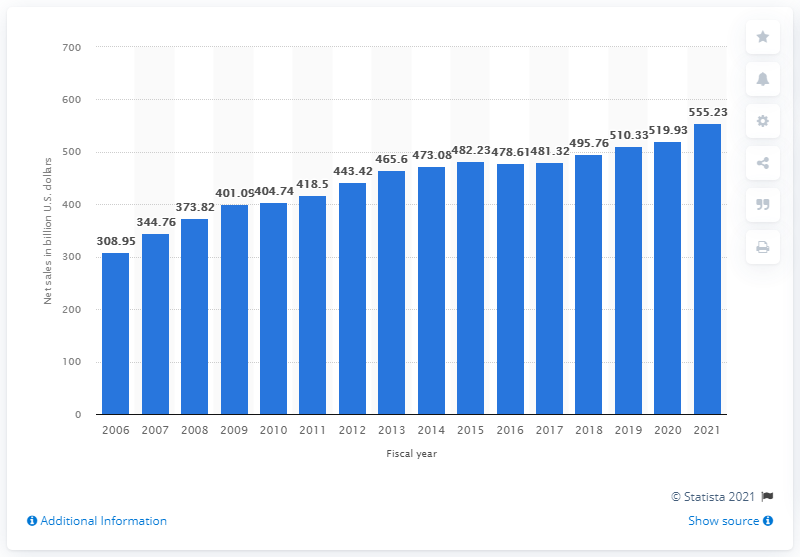Highlight a few significant elements in this photo. Walmart's global net sales increased by 555.23% in 2021 compared to a year earlier. In 2021, Walmart's global net sales totaled approximately $555.23 billion in U.S. dollars. 